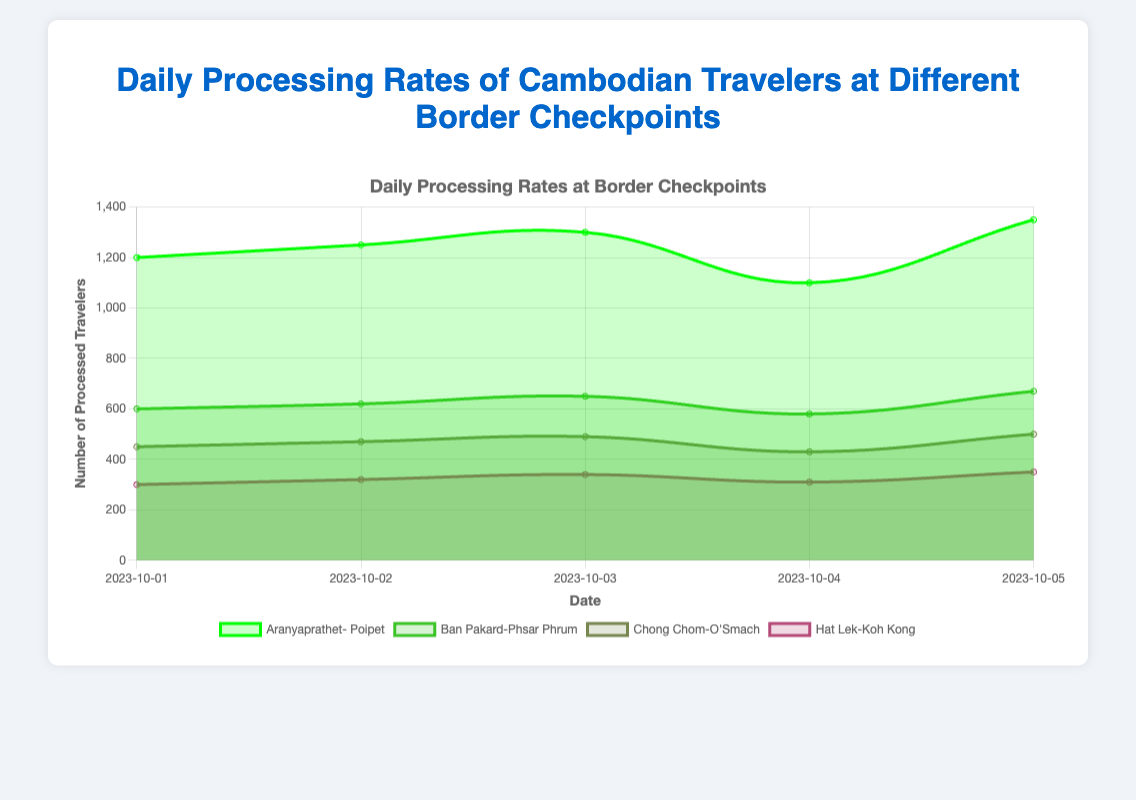What is the title of the chart? The title of the chart is usually located at the top of the figure. In this case, it reads "Daily Processing Rates of Cambodian Travelers at Different Border Checkpoints."
Answer: Daily Processing Rates of Cambodian Travelers at Different Border Checkpoints How many border checkpoints are represented in the chart? By observing the legend or the line labels, you can see there are four border checkpoints listed: Aranyaprathet-Poipet, Ban Pakard-Phsar Phrum, Chong Chom-O'Smach, and Hat Lek-Koh Kong.
Answer: Four Which border checkpoint processed the most travelers on October 3rd? To determine which checkpoint processed the most travelers on October 3rd, compare the values for each checkpoint on that date. Aranyaprathet-Poipet processed 1300 travelers, which is the highest.
Answer: Aranyaprathet-Poipet What is the overall trend for the number of travelers processed at Hat Lek-Koh Kong from October 1st to October 5th? By examining the area representing Hat Lek-Koh Kong, the number of travelers starts at 300 on October 1st and generally increases to 350 by October 5th, indicating an upward trend.
Answer: Upward trend Which checkpoint had the least variability in the number of processed travelers from October 1st to October 5th? To determine the checkpoint with the least variability, review the fluctuations in the area or line chart for each checkpoint. Chong Chom-O'Smach shows relatively consistent values, ranging from 430 to 500, indicating the least variability among the checkpoints.
Answer: Chong Chom-O'Smach On which date did Ban Pakard-Phsar Phrum have the lowest number of processed travelers? Look at the data for Ban Pakard-Phsar Phrum and find the date with the smallest value. On October 4th, this checkpoint processed 580 travelers, which is the lowest.
Answer: October 4th What is the average number of travelers processed daily at the Aranyaprathet-Poipet checkpoint from October 1st to October 5th? The daily processing numbers for Aranyaprathet-Poipet are 1200, 1250, 1300, 1100, and 1350. Summing these values gives 6200, and dividing by the number of days (5) gives an average of 1240.
Answer: 1240 Compare the maximum number of travelers processed in a single day at Chong Chom-O'Smach and Hat Lek-Koh Kong. Which one processed more and by how many? For Chong Chom-O'Smach, the maximum number is 500 (October 5th). For Hat Lek-Koh Kong, the maximum is 350 (October 5th). Chong Chom-O'Smach processed more travelers, with 150 more than Hat Lek-Koh Kong.
Answer: Chong Chom-O'Smach by 150 